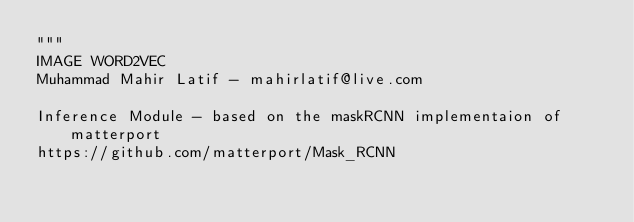Convert code to text. <code><loc_0><loc_0><loc_500><loc_500><_Python_>"""
IMAGE WORD2VEC
Muhammad Mahir Latif - mahirlatif@live.com

Inference Module - based on the maskRCNN implementaion of matterport
https://github.com/matterport/Mask_RCNN

</code> 